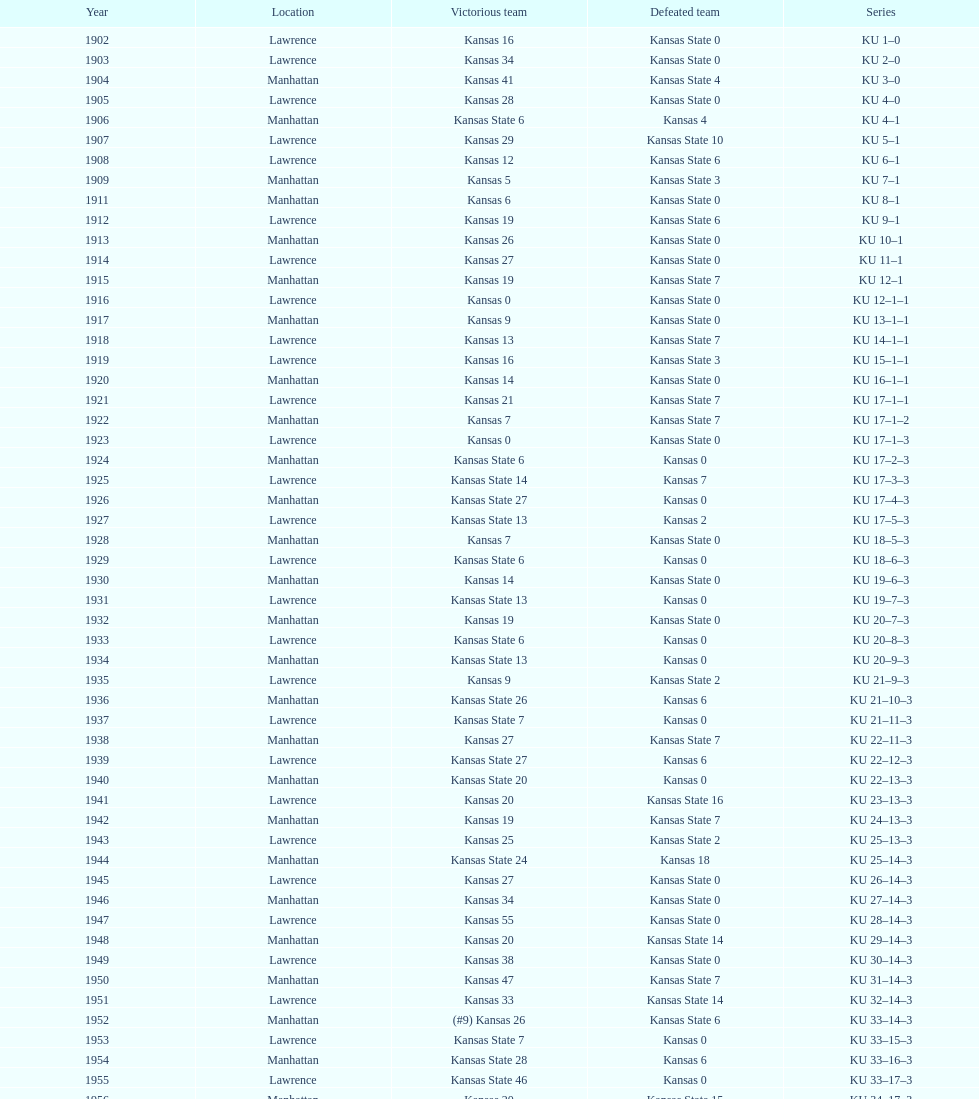Could you help me parse every detail presented in this table? {'header': ['Year', 'Location', 'Victorious team', 'Defeated team', 'Series'], 'rows': [['1902', 'Lawrence', 'Kansas 16', 'Kansas State 0', 'KU 1–0'], ['1903', 'Lawrence', 'Kansas 34', 'Kansas State 0', 'KU 2–0'], ['1904', 'Manhattan', 'Kansas 41', 'Kansas State 4', 'KU 3–0'], ['1905', 'Lawrence', 'Kansas 28', 'Kansas State 0', 'KU 4–0'], ['1906', 'Manhattan', 'Kansas State 6', 'Kansas 4', 'KU 4–1'], ['1907', 'Lawrence', 'Kansas 29', 'Kansas State 10', 'KU 5–1'], ['1908', 'Lawrence', 'Kansas 12', 'Kansas State 6', 'KU 6–1'], ['1909', 'Manhattan', 'Kansas 5', 'Kansas State 3', 'KU 7–1'], ['1911', 'Manhattan', 'Kansas 6', 'Kansas State 0', 'KU 8–1'], ['1912', 'Lawrence', 'Kansas 19', 'Kansas State 6', 'KU 9–1'], ['1913', 'Manhattan', 'Kansas 26', 'Kansas State 0', 'KU 10–1'], ['1914', 'Lawrence', 'Kansas 27', 'Kansas State 0', 'KU 11–1'], ['1915', 'Manhattan', 'Kansas 19', 'Kansas State 7', 'KU 12–1'], ['1916', 'Lawrence', 'Kansas 0', 'Kansas State 0', 'KU 12–1–1'], ['1917', 'Manhattan', 'Kansas 9', 'Kansas State 0', 'KU 13–1–1'], ['1918', 'Lawrence', 'Kansas 13', 'Kansas State 7', 'KU 14–1–1'], ['1919', 'Lawrence', 'Kansas 16', 'Kansas State 3', 'KU 15–1–1'], ['1920', 'Manhattan', 'Kansas 14', 'Kansas State 0', 'KU 16–1–1'], ['1921', 'Lawrence', 'Kansas 21', 'Kansas State 7', 'KU 17–1–1'], ['1922', 'Manhattan', 'Kansas 7', 'Kansas State 7', 'KU 17–1–2'], ['1923', 'Lawrence', 'Kansas 0', 'Kansas State 0', 'KU 17–1–3'], ['1924', 'Manhattan', 'Kansas State 6', 'Kansas 0', 'KU 17–2–3'], ['1925', 'Lawrence', 'Kansas State 14', 'Kansas 7', 'KU 17–3–3'], ['1926', 'Manhattan', 'Kansas State 27', 'Kansas 0', 'KU 17–4–3'], ['1927', 'Lawrence', 'Kansas State 13', 'Kansas 2', 'KU 17–5–3'], ['1928', 'Manhattan', 'Kansas 7', 'Kansas State 0', 'KU 18–5–3'], ['1929', 'Lawrence', 'Kansas State 6', 'Kansas 0', 'KU 18–6–3'], ['1930', 'Manhattan', 'Kansas 14', 'Kansas State 0', 'KU 19–6–3'], ['1931', 'Lawrence', 'Kansas State 13', 'Kansas 0', 'KU 19–7–3'], ['1932', 'Manhattan', 'Kansas 19', 'Kansas State 0', 'KU 20–7–3'], ['1933', 'Lawrence', 'Kansas State 6', 'Kansas 0', 'KU 20–8–3'], ['1934', 'Manhattan', 'Kansas State 13', 'Kansas 0', 'KU 20–9–3'], ['1935', 'Lawrence', 'Kansas 9', 'Kansas State 2', 'KU 21–9–3'], ['1936', 'Manhattan', 'Kansas State 26', 'Kansas 6', 'KU 21–10–3'], ['1937', 'Lawrence', 'Kansas State 7', 'Kansas 0', 'KU 21–11–3'], ['1938', 'Manhattan', 'Kansas 27', 'Kansas State 7', 'KU 22–11–3'], ['1939', 'Lawrence', 'Kansas State 27', 'Kansas 6', 'KU 22–12–3'], ['1940', 'Manhattan', 'Kansas State 20', 'Kansas 0', 'KU 22–13–3'], ['1941', 'Lawrence', 'Kansas 20', 'Kansas State 16', 'KU 23–13–3'], ['1942', 'Manhattan', 'Kansas 19', 'Kansas State 7', 'KU 24–13–3'], ['1943', 'Lawrence', 'Kansas 25', 'Kansas State 2', 'KU 25–13–3'], ['1944', 'Manhattan', 'Kansas State 24', 'Kansas 18', 'KU 25–14–3'], ['1945', 'Lawrence', 'Kansas 27', 'Kansas State 0', 'KU 26–14–3'], ['1946', 'Manhattan', 'Kansas 34', 'Kansas State 0', 'KU 27–14–3'], ['1947', 'Lawrence', 'Kansas 55', 'Kansas State 0', 'KU 28–14–3'], ['1948', 'Manhattan', 'Kansas 20', 'Kansas State 14', 'KU 29–14–3'], ['1949', 'Lawrence', 'Kansas 38', 'Kansas State 0', 'KU 30–14–3'], ['1950', 'Manhattan', 'Kansas 47', 'Kansas State 7', 'KU 31–14–3'], ['1951', 'Lawrence', 'Kansas 33', 'Kansas State 14', 'KU 32–14–3'], ['1952', 'Manhattan', '(#9) Kansas 26', 'Kansas State 6', 'KU 33–14–3'], ['1953', 'Lawrence', 'Kansas State 7', 'Kansas 0', 'KU 33–15–3'], ['1954', 'Manhattan', 'Kansas State 28', 'Kansas 6', 'KU 33–16–3'], ['1955', 'Lawrence', 'Kansas State 46', 'Kansas 0', 'KU 33–17–3'], ['1956', 'Manhattan', 'Kansas 20', 'Kansas State 15', 'KU 34–17–3'], ['1957', 'Lawrence', 'Kansas 13', 'Kansas State 7', 'KU 35–17–3'], ['1958', 'Manhattan', 'Kansas 21', 'Kansas State 12', 'KU 36–17–3'], ['1959', 'Lawrence', 'Kansas 33', 'Kansas State 14', 'KU 37–17–3'], ['1960', 'Manhattan', 'Kansas 41', 'Kansas State 0', 'KU 38–17–3'], ['1961', 'Lawrence', 'Kansas 34', 'Kansas State 0', 'KU 39–17–3'], ['1962', 'Manhattan', 'Kansas 38', 'Kansas State 0', 'KU 40–17–3'], ['1963', 'Lawrence', 'Kansas 34', 'Kansas State 0', 'KU 41–17–3'], ['1964', 'Manhattan', 'Kansas 7', 'Kansas State 0', 'KU 42–17–3'], ['1965', 'Lawrence', 'Kansas 34', 'Kansas State 0', 'KU 43–17–3'], ['1966', 'Manhattan', 'Kansas 3', 'Kansas State 3', 'KU 43–17–4'], ['1967', 'Lawrence', 'Kansas 17', 'Kansas State 16', 'KU 44–17–4'], ['1968', 'Manhattan', '(#7) Kansas 38', 'Kansas State 29', 'KU 45–17–4']]} How many times did kansas state not score at all against kansas from 1902-1968? 23. 